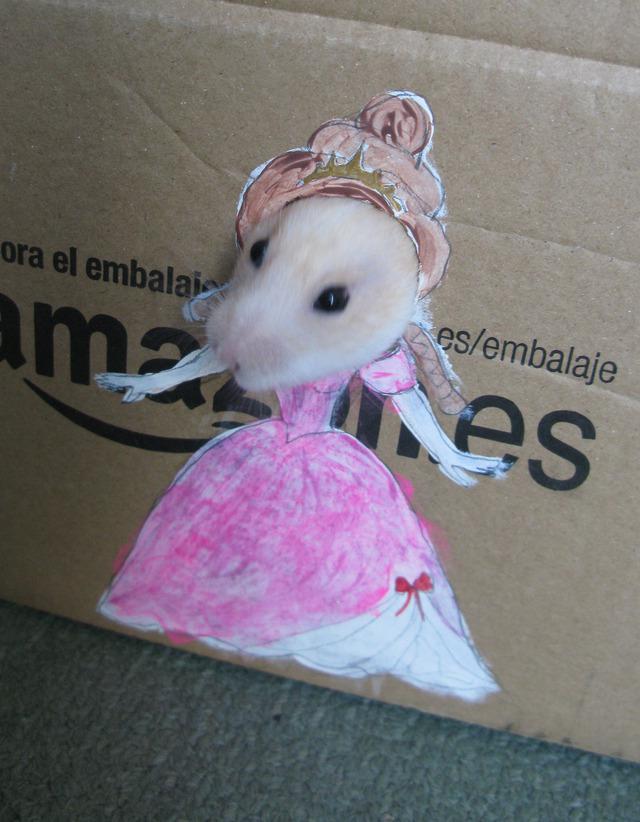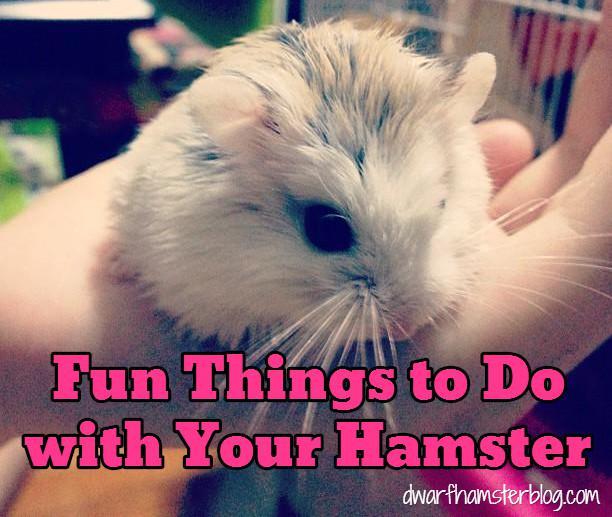The first image is the image on the left, the second image is the image on the right. Considering the images on both sides, is "In at least one of the images there is a rodent playing an instrument" valid? Answer yes or no. No. The first image is the image on the left, the second image is the image on the right. Evaluate the accuracy of this statement regarding the images: "There is at least one hamster playing a miniature saxophone.". Is it true? Answer yes or no. No. 